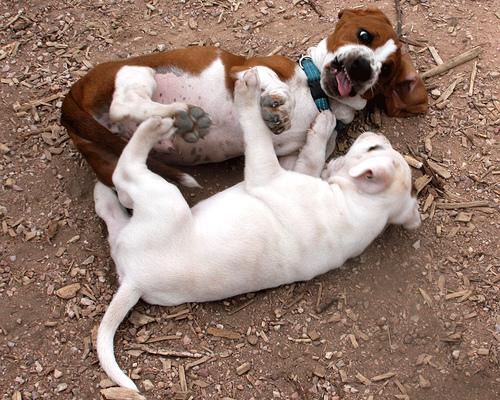Which dog has an owner?
Give a very brief answer. Both. Are the dogs related?
Keep it brief. No. What are the dogs doing?
Answer briefly. Playing. 